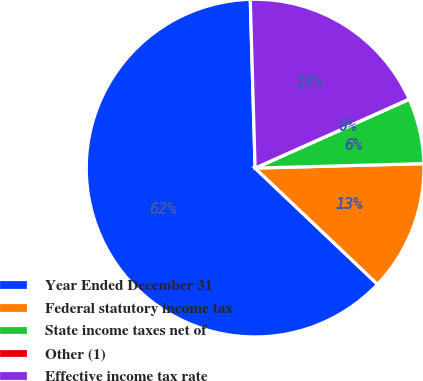Convert chart to OTSL. <chart><loc_0><loc_0><loc_500><loc_500><pie_chart><fcel>Year Ended December 31<fcel>Federal statutory income tax<fcel>State income taxes net of<fcel>Other (1)<fcel>Effective income tax rate<nl><fcel>62.45%<fcel>12.51%<fcel>6.26%<fcel>0.02%<fcel>18.75%<nl></chart> 